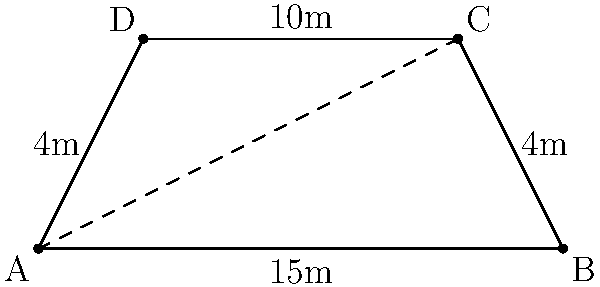You're designing a trapezoidal outdoor recovery area for rescued animals. The area has parallel sides of 15m and 10m, with a height of 4m. Calculate the total length of fencing needed to enclose this area, and determine its total area in square meters. To solve this problem, we'll follow these steps:

1. Calculate the perimeter (total fencing needed):
   - The perimeter is the sum of all sides of the trapezoid.
   - We have the parallel sides: 15m and 10m.
   - We need to calculate the length of the non-parallel sides using the Pythagorean theorem.

2. Calculate the length of a non-parallel side:
   - The difference in length between parallel sides is 15m - 10m = 5m.
   - Half of this difference is 2.5m (as the trapezoid is symmetrical).
   - Using the Pythagorean theorem: $\sqrt{2.5^2 + 4^2} = \sqrt{6.25 + 16} = \sqrt{22.25} \approx 4.72$ m

3. Calculate the perimeter:
   $15 + 10 + 4.72 + 4.72 = 34.44$ m

4. Calculate the area of the trapezoid:
   - Area of a trapezoid = $\frac{1}{2}(a+b)h$, where a and b are parallel sides and h is height.
   - Area = $\frac{1}{2}(15 + 10) \times 4 = \frac{1}{2} \times 25 \times 4 = 50$ sq m

Therefore, the total fencing needed is approximately 34.44 meters, and the area of the recovery space is 50 square meters.
Answer: 34.44 m of fencing; 50 sq m area 